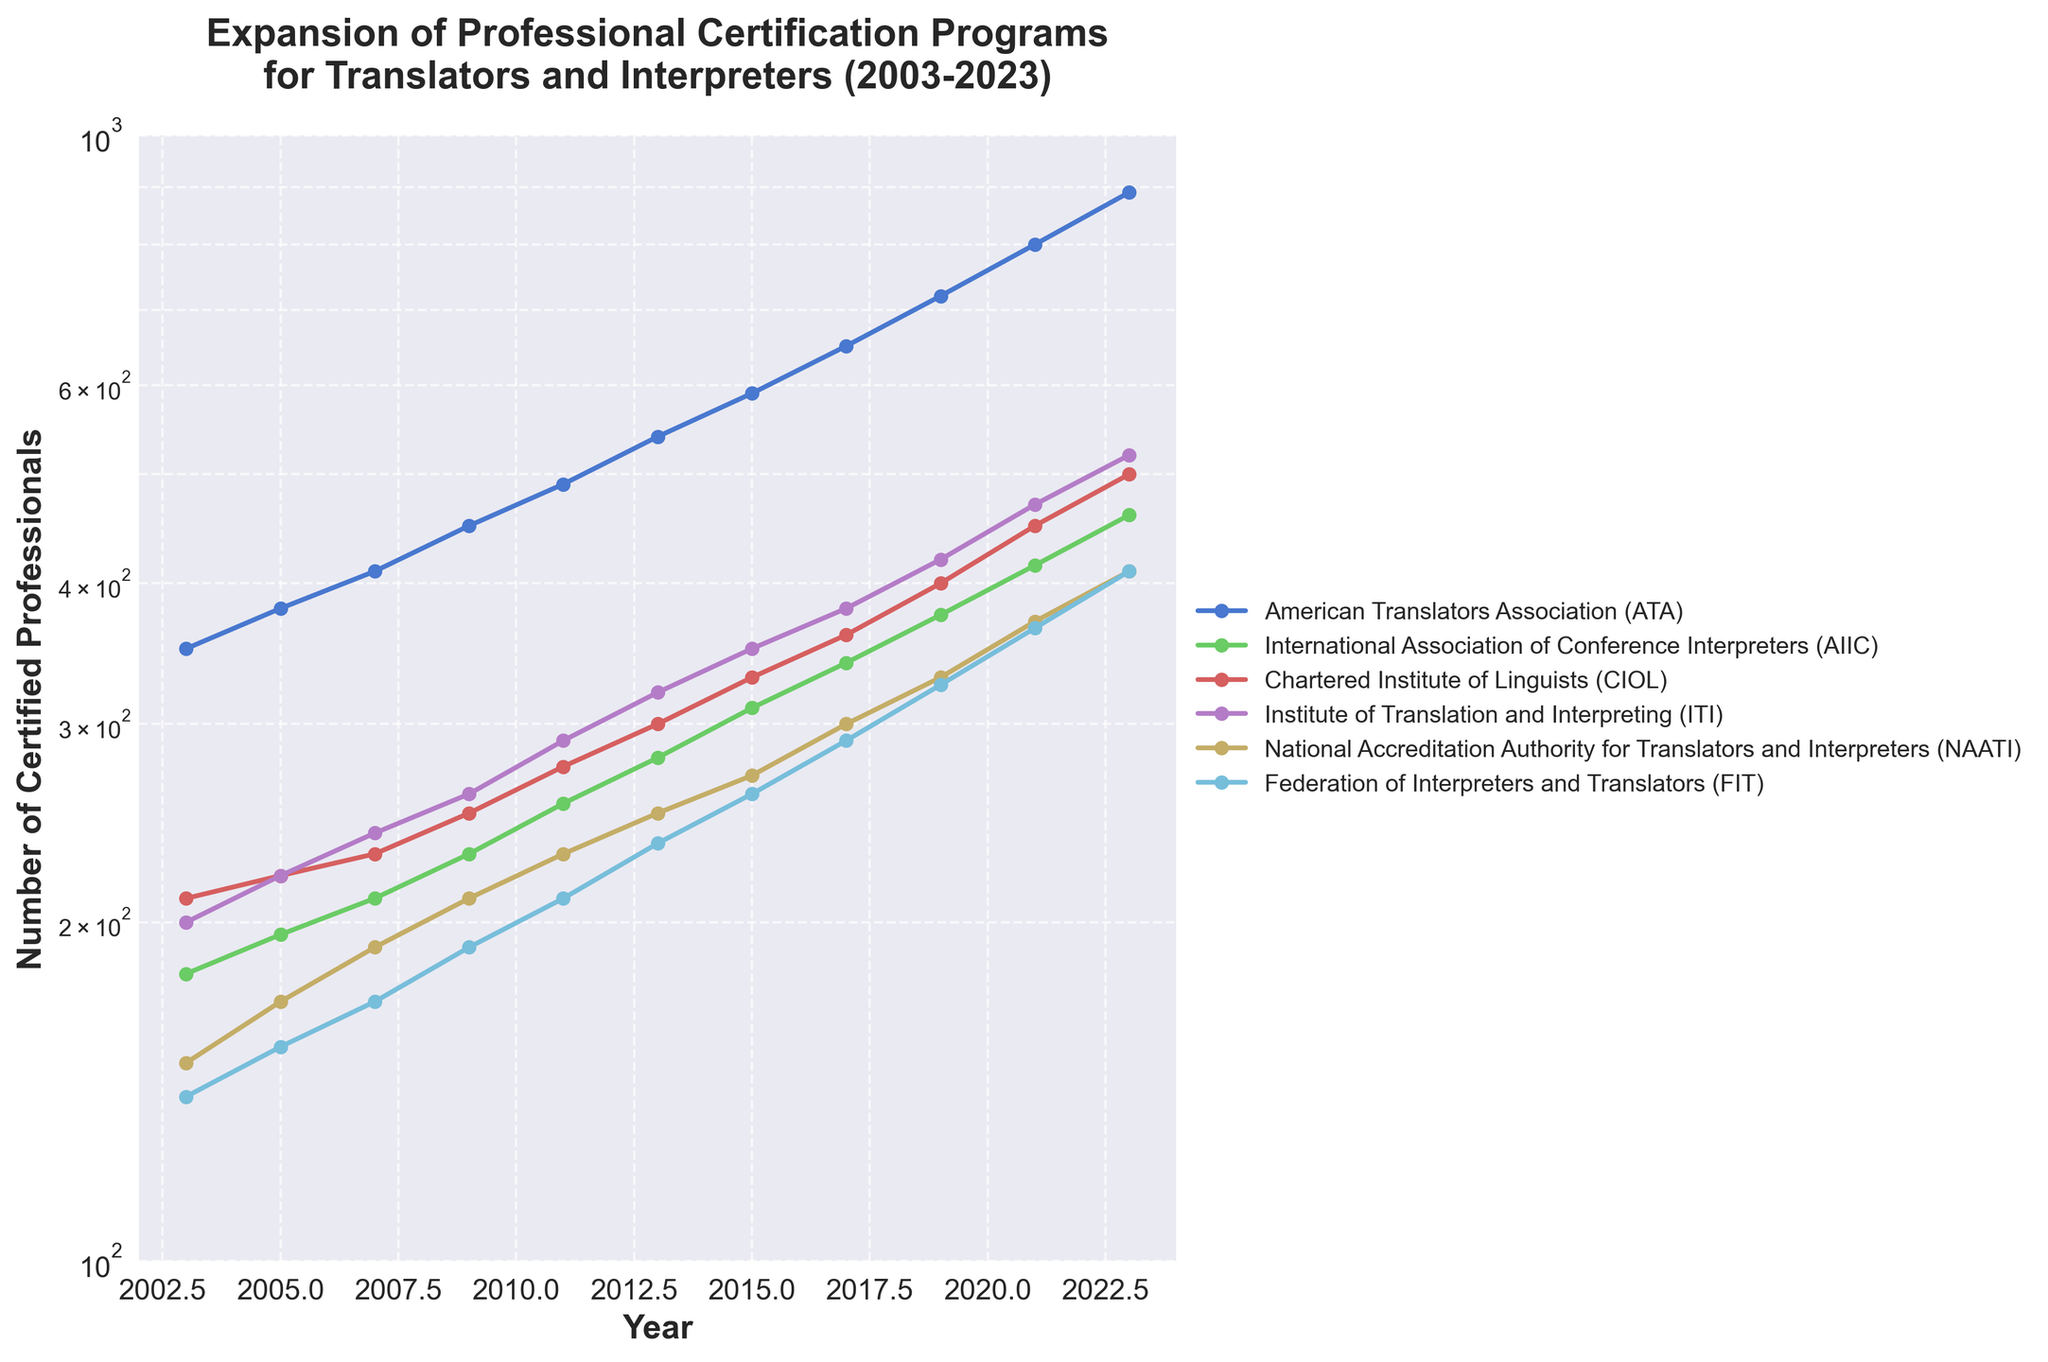What's the title of the figure? The title of a figure is usually written at the top of the chart. It provides a brief description of what the chart is about.
Answer: Expansion of Professional Certification Programs for Translators and Interpreters (2003-2023) How many organizations are represented in the figure? To find the number of organizations represented, count the number of lines or check the legend of the plot which labels each organization.
Answer: 6 What organization's certification programs saw the most growth from 2003 to 2023? Compare the starting and ending values for each organization's line in the plot from 2003 to 2023. The organization with the largest increase in certified professionals experienced the most growth.
Answer: American Translators Association (ATA) In which year did the International Association of Conference Interpreters (AIIC) reach 300 certified professionals? Find the AIIC line on the plot and observe the year when the y-axis value first crosses 300.
Answer: 2015 Which organization had the highest number of certified professionals in 2009? Look at the highest point on the graph for the year 2009 and check the corresponding organization in the legend.
Answer: American Translators Association (ATA) What is the difference in the number of certified professionals between the National Accreditation Authority for Translators and Interpreters (NAATI) and Federation of Interpreters and Translators (FIT) in 2021? Locate the points for both NAATI and FIT in 2021. Subtract the value of FIT from NAATI to get the difference.
Answer: 5 Which organizations had over 500 certified professionals by 2023? Check the lines on the plot and see which ones are at or above the 500 mark on the y-axis by the year 2023.
Answer: ATA, AIIC, CIOL, ITI Between 2003 and 2005, which organization had the smallest increase in the number of certified professionals? Calculate the difference in the number of certified professionals between 2003 and 2005 for each organization. The one with the smallest increase is the answer.
Answer: Chartered Institute of Linguists (CIOL) How many years did it take for the American Translators Association (ATA) to double its certification numbers from 2003 levels? Identify the certification number for ATA in 2003, then find the year when it was roughly double that number and calculate the difference in years.
Answer: 14 years Compare the growth rates of CIOL and ITI from 2010 to 2020. Which organization experienced faster growth? Calculate the difference in certification numbers for CIOL and ITI for the years 2010 and 2020. Compare these growth values to determine which is larger.
Answer: ITI 